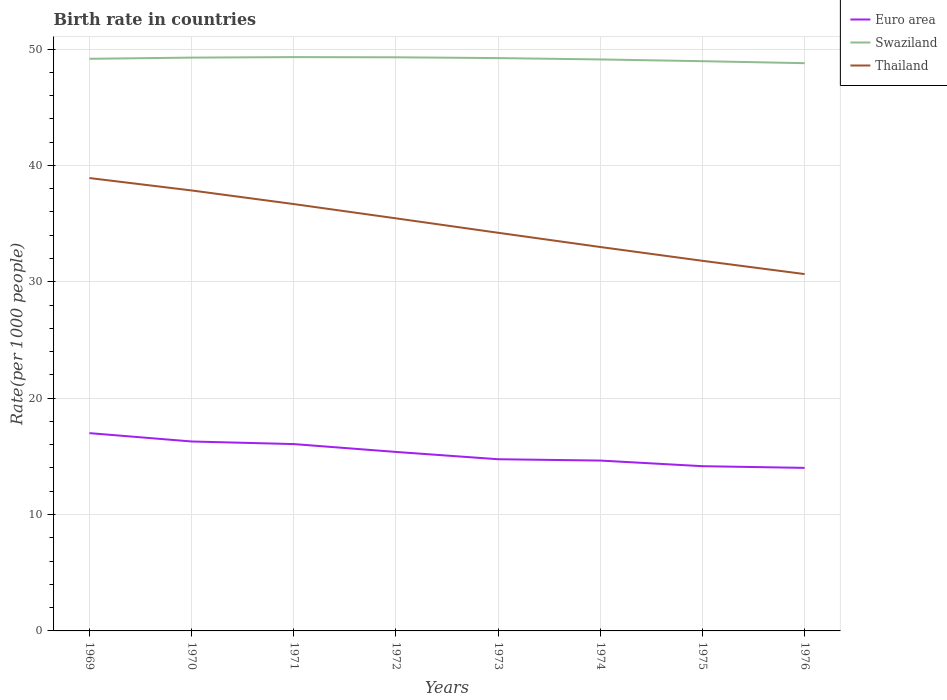How many different coloured lines are there?
Offer a very short reply. 3. Does the line corresponding to Thailand intersect with the line corresponding to Euro area?
Your response must be concise. No. Is the number of lines equal to the number of legend labels?
Offer a very short reply. Yes. Across all years, what is the maximum birth rate in Thailand?
Ensure brevity in your answer.  30.66. In which year was the birth rate in Euro area maximum?
Give a very brief answer. 1976. What is the total birth rate in Thailand in the graph?
Offer a very short reply. 1.24. What is the difference between the highest and the second highest birth rate in Euro area?
Provide a short and direct response. 2.99. What is the difference between the highest and the lowest birth rate in Swaziland?
Keep it short and to the point. 5. Is the birth rate in Euro area strictly greater than the birth rate in Thailand over the years?
Give a very brief answer. Yes. What is the difference between two consecutive major ticks on the Y-axis?
Your answer should be very brief. 10. Where does the legend appear in the graph?
Make the answer very short. Top right. How are the legend labels stacked?
Your answer should be very brief. Vertical. What is the title of the graph?
Provide a succinct answer. Birth rate in countries. Does "Heavily indebted poor countries" appear as one of the legend labels in the graph?
Offer a very short reply. No. What is the label or title of the Y-axis?
Offer a terse response. Rate(per 1000 people). What is the Rate(per 1000 people) of Euro area in 1969?
Make the answer very short. 17. What is the Rate(per 1000 people) in Swaziland in 1969?
Make the answer very short. 49.16. What is the Rate(per 1000 people) of Thailand in 1969?
Give a very brief answer. 38.91. What is the Rate(per 1000 people) of Euro area in 1970?
Your response must be concise. 16.28. What is the Rate(per 1000 people) in Swaziland in 1970?
Provide a short and direct response. 49.26. What is the Rate(per 1000 people) of Thailand in 1970?
Offer a very short reply. 37.85. What is the Rate(per 1000 people) of Euro area in 1971?
Keep it short and to the point. 16.05. What is the Rate(per 1000 people) in Swaziland in 1971?
Your answer should be very brief. 49.3. What is the Rate(per 1000 people) of Thailand in 1971?
Ensure brevity in your answer.  36.68. What is the Rate(per 1000 people) of Euro area in 1972?
Your answer should be very brief. 15.38. What is the Rate(per 1000 people) in Swaziland in 1972?
Offer a terse response. 49.29. What is the Rate(per 1000 people) in Thailand in 1972?
Your response must be concise. 35.45. What is the Rate(per 1000 people) in Euro area in 1973?
Keep it short and to the point. 14.75. What is the Rate(per 1000 people) of Swaziland in 1973?
Ensure brevity in your answer.  49.22. What is the Rate(per 1000 people) in Thailand in 1973?
Provide a short and direct response. 34.21. What is the Rate(per 1000 people) in Euro area in 1974?
Make the answer very short. 14.64. What is the Rate(per 1000 people) of Swaziland in 1974?
Keep it short and to the point. 49.1. What is the Rate(per 1000 people) of Thailand in 1974?
Provide a succinct answer. 32.99. What is the Rate(per 1000 people) in Euro area in 1975?
Provide a short and direct response. 14.15. What is the Rate(per 1000 people) of Swaziland in 1975?
Ensure brevity in your answer.  48.95. What is the Rate(per 1000 people) of Thailand in 1975?
Your answer should be very brief. 31.8. What is the Rate(per 1000 people) in Euro area in 1976?
Give a very brief answer. 14.01. What is the Rate(per 1000 people) of Swaziland in 1976?
Your response must be concise. 48.78. What is the Rate(per 1000 people) of Thailand in 1976?
Make the answer very short. 30.66. Across all years, what is the maximum Rate(per 1000 people) of Euro area?
Your answer should be very brief. 17. Across all years, what is the maximum Rate(per 1000 people) of Swaziland?
Give a very brief answer. 49.3. Across all years, what is the maximum Rate(per 1000 people) of Thailand?
Your answer should be very brief. 38.91. Across all years, what is the minimum Rate(per 1000 people) in Euro area?
Provide a succinct answer. 14.01. Across all years, what is the minimum Rate(per 1000 people) of Swaziland?
Your answer should be very brief. 48.78. Across all years, what is the minimum Rate(per 1000 people) of Thailand?
Offer a very short reply. 30.66. What is the total Rate(per 1000 people) in Euro area in the graph?
Offer a terse response. 122.26. What is the total Rate(per 1000 people) in Swaziland in the graph?
Offer a very short reply. 393.08. What is the total Rate(per 1000 people) of Thailand in the graph?
Provide a short and direct response. 278.55. What is the difference between the Rate(per 1000 people) of Euro area in 1969 and that in 1970?
Your answer should be compact. 0.72. What is the difference between the Rate(per 1000 people) in Swaziland in 1969 and that in 1970?
Provide a succinct answer. -0.1. What is the difference between the Rate(per 1000 people) of Thailand in 1969 and that in 1970?
Ensure brevity in your answer.  1.07. What is the difference between the Rate(per 1000 people) in Euro area in 1969 and that in 1971?
Keep it short and to the point. 0.94. What is the difference between the Rate(per 1000 people) of Swaziland in 1969 and that in 1971?
Keep it short and to the point. -0.14. What is the difference between the Rate(per 1000 people) in Thailand in 1969 and that in 1971?
Your response must be concise. 2.24. What is the difference between the Rate(per 1000 people) of Euro area in 1969 and that in 1972?
Ensure brevity in your answer.  1.62. What is the difference between the Rate(per 1000 people) in Swaziland in 1969 and that in 1972?
Give a very brief answer. -0.13. What is the difference between the Rate(per 1000 people) in Thailand in 1969 and that in 1972?
Offer a terse response. 3.46. What is the difference between the Rate(per 1000 people) of Euro area in 1969 and that in 1973?
Provide a succinct answer. 2.24. What is the difference between the Rate(per 1000 people) in Swaziland in 1969 and that in 1973?
Offer a very short reply. -0.06. What is the difference between the Rate(per 1000 people) in Thailand in 1969 and that in 1973?
Make the answer very short. 4.7. What is the difference between the Rate(per 1000 people) in Euro area in 1969 and that in 1974?
Your answer should be very brief. 2.36. What is the difference between the Rate(per 1000 people) of Swaziland in 1969 and that in 1974?
Your answer should be very brief. 0.06. What is the difference between the Rate(per 1000 people) in Thailand in 1969 and that in 1974?
Ensure brevity in your answer.  5.92. What is the difference between the Rate(per 1000 people) of Euro area in 1969 and that in 1975?
Make the answer very short. 2.84. What is the difference between the Rate(per 1000 people) in Swaziland in 1969 and that in 1975?
Your answer should be compact. 0.2. What is the difference between the Rate(per 1000 people) in Thailand in 1969 and that in 1975?
Your answer should be very brief. 7.11. What is the difference between the Rate(per 1000 people) in Euro area in 1969 and that in 1976?
Provide a short and direct response. 2.99. What is the difference between the Rate(per 1000 people) in Thailand in 1969 and that in 1976?
Ensure brevity in your answer.  8.25. What is the difference between the Rate(per 1000 people) of Euro area in 1970 and that in 1971?
Offer a terse response. 0.22. What is the difference between the Rate(per 1000 people) of Swaziland in 1970 and that in 1971?
Provide a succinct answer. -0.04. What is the difference between the Rate(per 1000 people) of Thailand in 1970 and that in 1971?
Provide a short and direct response. 1.17. What is the difference between the Rate(per 1000 people) in Euro area in 1970 and that in 1972?
Keep it short and to the point. 0.9. What is the difference between the Rate(per 1000 people) in Swaziland in 1970 and that in 1972?
Your answer should be compact. -0.03. What is the difference between the Rate(per 1000 people) in Thailand in 1970 and that in 1972?
Ensure brevity in your answer.  2.4. What is the difference between the Rate(per 1000 people) of Euro area in 1970 and that in 1973?
Offer a very short reply. 1.53. What is the difference between the Rate(per 1000 people) of Swaziland in 1970 and that in 1973?
Provide a succinct answer. 0.04. What is the difference between the Rate(per 1000 people) in Thailand in 1970 and that in 1973?
Offer a terse response. 3.64. What is the difference between the Rate(per 1000 people) in Euro area in 1970 and that in 1974?
Offer a very short reply. 1.64. What is the difference between the Rate(per 1000 people) in Swaziland in 1970 and that in 1974?
Your response must be concise. 0.16. What is the difference between the Rate(per 1000 people) in Thailand in 1970 and that in 1974?
Your answer should be very brief. 4.86. What is the difference between the Rate(per 1000 people) of Euro area in 1970 and that in 1975?
Your answer should be very brief. 2.12. What is the difference between the Rate(per 1000 people) in Swaziland in 1970 and that in 1975?
Keep it short and to the point. 0.31. What is the difference between the Rate(per 1000 people) in Thailand in 1970 and that in 1975?
Your answer should be very brief. 6.04. What is the difference between the Rate(per 1000 people) in Euro area in 1970 and that in 1976?
Make the answer very short. 2.27. What is the difference between the Rate(per 1000 people) of Swaziland in 1970 and that in 1976?
Offer a very short reply. 0.48. What is the difference between the Rate(per 1000 people) in Thailand in 1970 and that in 1976?
Offer a very short reply. 7.19. What is the difference between the Rate(per 1000 people) of Euro area in 1971 and that in 1972?
Your answer should be very brief. 0.68. What is the difference between the Rate(per 1000 people) in Swaziland in 1971 and that in 1972?
Your answer should be very brief. 0.02. What is the difference between the Rate(per 1000 people) in Thailand in 1971 and that in 1972?
Provide a succinct answer. 1.23. What is the difference between the Rate(per 1000 people) in Euro area in 1971 and that in 1973?
Ensure brevity in your answer.  1.3. What is the difference between the Rate(per 1000 people) of Swaziland in 1971 and that in 1973?
Keep it short and to the point. 0.08. What is the difference between the Rate(per 1000 people) in Thailand in 1971 and that in 1973?
Your response must be concise. 2.47. What is the difference between the Rate(per 1000 people) of Euro area in 1971 and that in 1974?
Give a very brief answer. 1.42. What is the difference between the Rate(per 1000 people) in Thailand in 1971 and that in 1974?
Offer a terse response. 3.69. What is the difference between the Rate(per 1000 people) of Euro area in 1971 and that in 1975?
Provide a short and direct response. 1.9. What is the difference between the Rate(per 1000 people) of Swaziland in 1971 and that in 1975?
Make the answer very short. 0.35. What is the difference between the Rate(per 1000 people) in Thailand in 1971 and that in 1975?
Give a very brief answer. 4.88. What is the difference between the Rate(per 1000 people) of Euro area in 1971 and that in 1976?
Make the answer very short. 2.04. What is the difference between the Rate(per 1000 people) in Swaziland in 1971 and that in 1976?
Ensure brevity in your answer.  0.52. What is the difference between the Rate(per 1000 people) in Thailand in 1971 and that in 1976?
Your answer should be very brief. 6.02. What is the difference between the Rate(per 1000 people) in Euro area in 1972 and that in 1973?
Provide a short and direct response. 0.63. What is the difference between the Rate(per 1000 people) of Swaziland in 1972 and that in 1973?
Ensure brevity in your answer.  0.07. What is the difference between the Rate(per 1000 people) of Thailand in 1972 and that in 1973?
Keep it short and to the point. 1.24. What is the difference between the Rate(per 1000 people) of Euro area in 1972 and that in 1974?
Make the answer very short. 0.74. What is the difference between the Rate(per 1000 people) of Swaziland in 1972 and that in 1974?
Provide a short and direct response. 0.18. What is the difference between the Rate(per 1000 people) in Thailand in 1972 and that in 1974?
Ensure brevity in your answer.  2.46. What is the difference between the Rate(per 1000 people) of Euro area in 1972 and that in 1975?
Give a very brief answer. 1.22. What is the difference between the Rate(per 1000 people) in Swaziland in 1972 and that in 1975?
Your answer should be very brief. 0.33. What is the difference between the Rate(per 1000 people) of Thailand in 1972 and that in 1975?
Your answer should be compact. 3.65. What is the difference between the Rate(per 1000 people) in Euro area in 1972 and that in 1976?
Provide a succinct answer. 1.37. What is the difference between the Rate(per 1000 people) in Swaziland in 1972 and that in 1976?
Your response must be concise. 0.5. What is the difference between the Rate(per 1000 people) in Thailand in 1972 and that in 1976?
Make the answer very short. 4.79. What is the difference between the Rate(per 1000 people) of Euro area in 1973 and that in 1974?
Provide a short and direct response. 0.11. What is the difference between the Rate(per 1000 people) in Swaziland in 1973 and that in 1974?
Ensure brevity in your answer.  0.12. What is the difference between the Rate(per 1000 people) in Thailand in 1973 and that in 1974?
Your answer should be very brief. 1.22. What is the difference between the Rate(per 1000 people) in Euro area in 1973 and that in 1975?
Provide a short and direct response. 0.6. What is the difference between the Rate(per 1000 people) of Swaziland in 1973 and that in 1975?
Make the answer very short. 0.27. What is the difference between the Rate(per 1000 people) of Thailand in 1973 and that in 1975?
Provide a short and direct response. 2.41. What is the difference between the Rate(per 1000 people) of Euro area in 1973 and that in 1976?
Ensure brevity in your answer.  0.74. What is the difference between the Rate(per 1000 people) of Swaziland in 1973 and that in 1976?
Your answer should be very brief. 0.44. What is the difference between the Rate(per 1000 people) of Thailand in 1973 and that in 1976?
Give a very brief answer. 3.55. What is the difference between the Rate(per 1000 people) in Euro area in 1974 and that in 1975?
Your answer should be compact. 0.48. What is the difference between the Rate(per 1000 people) of Swaziland in 1974 and that in 1975?
Provide a succinct answer. 0.15. What is the difference between the Rate(per 1000 people) in Thailand in 1974 and that in 1975?
Offer a terse response. 1.19. What is the difference between the Rate(per 1000 people) of Euro area in 1974 and that in 1976?
Make the answer very short. 0.63. What is the difference between the Rate(per 1000 people) in Swaziland in 1974 and that in 1976?
Keep it short and to the point. 0.32. What is the difference between the Rate(per 1000 people) in Thailand in 1974 and that in 1976?
Ensure brevity in your answer.  2.33. What is the difference between the Rate(per 1000 people) in Euro area in 1975 and that in 1976?
Your response must be concise. 0.14. What is the difference between the Rate(per 1000 people) in Swaziland in 1975 and that in 1976?
Your answer should be very brief. 0.17. What is the difference between the Rate(per 1000 people) in Thailand in 1975 and that in 1976?
Your answer should be very brief. 1.14. What is the difference between the Rate(per 1000 people) of Euro area in 1969 and the Rate(per 1000 people) of Swaziland in 1970?
Offer a terse response. -32.27. What is the difference between the Rate(per 1000 people) of Euro area in 1969 and the Rate(per 1000 people) of Thailand in 1970?
Give a very brief answer. -20.85. What is the difference between the Rate(per 1000 people) in Swaziland in 1969 and the Rate(per 1000 people) in Thailand in 1970?
Offer a terse response. 11.31. What is the difference between the Rate(per 1000 people) of Euro area in 1969 and the Rate(per 1000 people) of Swaziland in 1971?
Your response must be concise. -32.31. What is the difference between the Rate(per 1000 people) of Euro area in 1969 and the Rate(per 1000 people) of Thailand in 1971?
Offer a terse response. -19.68. What is the difference between the Rate(per 1000 people) in Swaziland in 1969 and the Rate(per 1000 people) in Thailand in 1971?
Ensure brevity in your answer.  12.48. What is the difference between the Rate(per 1000 people) of Euro area in 1969 and the Rate(per 1000 people) of Swaziland in 1972?
Your answer should be very brief. -32.29. What is the difference between the Rate(per 1000 people) of Euro area in 1969 and the Rate(per 1000 people) of Thailand in 1972?
Give a very brief answer. -18.46. What is the difference between the Rate(per 1000 people) of Swaziland in 1969 and the Rate(per 1000 people) of Thailand in 1972?
Your answer should be very brief. 13.71. What is the difference between the Rate(per 1000 people) of Euro area in 1969 and the Rate(per 1000 people) of Swaziland in 1973?
Give a very brief answer. -32.23. What is the difference between the Rate(per 1000 people) in Euro area in 1969 and the Rate(per 1000 people) in Thailand in 1973?
Give a very brief answer. -17.22. What is the difference between the Rate(per 1000 people) of Swaziland in 1969 and the Rate(per 1000 people) of Thailand in 1973?
Offer a terse response. 14.95. What is the difference between the Rate(per 1000 people) in Euro area in 1969 and the Rate(per 1000 people) in Swaziland in 1974?
Make the answer very short. -32.11. What is the difference between the Rate(per 1000 people) of Euro area in 1969 and the Rate(per 1000 people) of Thailand in 1974?
Provide a succinct answer. -15.99. What is the difference between the Rate(per 1000 people) of Swaziland in 1969 and the Rate(per 1000 people) of Thailand in 1974?
Your answer should be compact. 16.17. What is the difference between the Rate(per 1000 people) in Euro area in 1969 and the Rate(per 1000 people) in Swaziland in 1975?
Offer a terse response. -31.96. What is the difference between the Rate(per 1000 people) in Euro area in 1969 and the Rate(per 1000 people) in Thailand in 1975?
Your response must be concise. -14.81. What is the difference between the Rate(per 1000 people) in Swaziland in 1969 and the Rate(per 1000 people) in Thailand in 1975?
Ensure brevity in your answer.  17.36. What is the difference between the Rate(per 1000 people) in Euro area in 1969 and the Rate(per 1000 people) in Swaziland in 1976?
Your answer should be compact. -31.79. What is the difference between the Rate(per 1000 people) in Euro area in 1969 and the Rate(per 1000 people) in Thailand in 1976?
Make the answer very short. -13.67. What is the difference between the Rate(per 1000 people) of Swaziland in 1969 and the Rate(per 1000 people) of Thailand in 1976?
Your answer should be very brief. 18.5. What is the difference between the Rate(per 1000 people) in Euro area in 1970 and the Rate(per 1000 people) in Swaziland in 1971?
Your answer should be very brief. -33.03. What is the difference between the Rate(per 1000 people) in Euro area in 1970 and the Rate(per 1000 people) in Thailand in 1971?
Make the answer very short. -20.4. What is the difference between the Rate(per 1000 people) of Swaziland in 1970 and the Rate(per 1000 people) of Thailand in 1971?
Ensure brevity in your answer.  12.59. What is the difference between the Rate(per 1000 people) of Euro area in 1970 and the Rate(per 1000 people) of Swaziland in 1972?
Give a very brief answer. -33.01. What is the difference between the Rate(per 1000 people) in Euro area in 1970 and the Rate(per 1000 people) in Thailand in 1972?
Keep it short and to the point. -19.17. What is the difference between the Rate(per 1000 people) in Swaziland in 1970 and the Rate(per 1000 people) in Thailand in 1972?
Provide a short and direct response. 13.81. What is the difference between the Rate(per 1000 people) of Euro area in 1970 and the Rate(per 1000 people) of Swaziland in 1973?
Make the answer very short. -32.94. What is the difference between the Rate(per 1000 people) of Euro area in 1970 and the Rate(per 1000 people) of Thailand in 1973?
Keep it short and to the point. -17.93. What is the difference between the Rate(per 1000 people) in Swaziland in 1970 and the Rate(per 1000 people) in Thailand in 1973?
Give a very brief answer. 15.05. What is the difference between the Rate(per 1000 people) in Euro area in 1970 and the Rate(per 1000 people) in Swaziland in 1974?
Your answer should be very brief. -32.83. What is the difference between the Rate(per 1000 people) in Euro area in 1970 and the Rate(per 1000 people) in Thailand in 1974?
Ensure brevity in your answer.  -16.71. What is the difference between the Rate(per 1000 people) of Swaziland in 1970 and the Rate(per 1000 people) of Thailand in 1974?
Give a very brief answer. 16.27. What is the difference between the Rate(per 1000 people) of Euro area in 1970 and the Rate(per 1000 people) of Swaziland in 1975?
Your answer should be compact. -32.68. What is the difference between the Rate(per 1000 people) in Euro area in 1970 and the Rate(per 1000 people) in Thailand in 1975?
Keep it short and to the point. -15.52. What is the difference between the Rate(per 1000 people) of Swaziland in 1970 and the Rate(per 1000 people) of Thailand in 1975?
Offer a terse response. 17.46. What is the difference between the Rate(per 1000 people) in Euro area in 1970 and the Rate(per 1000 people) in Swaziland in 1976?
Make the answer very short. -32.51. What is the difference between the Rate(per 1000 people) in Euro area in 1970 and the Rate(per 1000 people) in Thailand in 1976?
Give a very brief answer. -14.38. What is the difference between the Rate(per 1000 people) in Swaziland in 1970 and the Rate(per 1000 people) in Thailand in 1976?
Provide a short and direct response. 18.6. What is the difference between the Rate(per 1000 people) of Euro area in 1971 and the Rate(per 1000 people) of Swaziland in 1972?
Your response must be concise. -33.23. What is the difference between the Rate(per 1000 people) of Euro area in 1971 and the Rate(per 1000 people) of Thailand in 1972?
Provide a short and direct response. -19.4. What is the difference between the Rate(per 1000 people) in Swaziland in 1971 and the Rate(per 1000 people) in Thailand in 1972?
Provide a short and direct response. 13.85. What is the difference between the Rate(per 1000 people) of Euro area in 1971 and the Rate(per 1000 people) of Swaziland in 1973?
Offer a terse response. -33.17. What is the difference between the Rate(per 1000 people) of Euro area in 1971 and the Rate(per 1000 people) of Thailand in 1973?
Keep it short and to the point. -18.16. What is the difference between the Rate(per 1000 people) of Swaziland in 1971 and the Rate(per 1000 people) of Thailand in 1973?
Your answer should be very brief. 15.09. What is the difference between the Rate(per 1000 people) of Euro area in 1971 and the Rate(per 1000 people) of Swaziland in 1974?
Your answer should be compact. -33.05. What is the difference between the Rate(per 1000 people) of Euro area in 1971 and the Rate(per 1000 people) of Thailand in 1974?
Provide a succinct answer. -16.93. What is the difference between the Rate(per 1000 people) in Swaziland in 1971 and the Rate(per 1000 people) in Thailand in 1974?
Give a very brief answer. 16.32. What is the difference between the Rate(per 1000 people) in Euro area in 1971 and the Rate(per 1000 people) in Swaziland in 1975?
Ensure brevity in your answer.  -32.9. What is the difference between the Rate(per 1000 people) in Euro area in 1971 and the Rate(per 1000 people) in Thailand in 1975?
Your response must be concise. -15.75. What is the difference between the Rate(per 1000 people) of Swaziland in 1971 and the Rate(per 1000 people) of Thailand in 1975?
Your answer should be very brief. 17.5. What is the difference between the Rate(per 1000 people) in Euro area in 1971 and the Rate(per 1000 people) in Swaziland in 1976?
Ensure brevity in your answer.  -32.73. What is the difference between the Rate(per 1000 people) of Euro area in 1971 and the Rate(per 1000 people) of Thailand in 1976?
Your answer should be very brief. -14.61. What is the difference between the Rate(per 1000 people) of Swaziland in 1971 and the Rate(per 1000 people) of Thailand in 1976?
Ensure brevity in your answer.  18.64. What is the difference between the Rate(per 1000 people) of Euro area in 1972 and the Rate(per 1000 people) of Swaziland in 1973?
Provide a short and direct response. -33.84. What is the difference between the Rate(per 1000 people) in Euro area in 1972 and the Rate(per 1000 people) in Thailand in 1973?
Give a very brief answer. -18.83. What is the difference between the Rate(per 1000 people) of Swaziland in 1972 and the Rate(per 1000 people) of Thailand in 1973?
Make the answer very short. 15.08. What is the difference between the Rate(per 1000 people) in Euro area in 1972 and the Rate(per 1000 people) in Swaziland in 1974?
Offer a terse response. -33.73. What is the difference between the Rate(per 1000 people) in Euro area in 1972 and the Rate(per 1000 people) in Thailand in 1974?
Keep it short and to the point. -17.61. What is the difference between the Rate(per 1000 people) in Swaziland in 1972 and the Rate(per 1000 people) in Thailand in 1974?
Give a very brief answer. 16.3. What is the difference between the Rate(per 1000 people) of Euro area in 1972 and the Rate(per 1000 people) of Swaziland in 1975?
Provide a succinct answer. -33.58. What is the difference between the Rate(per 1000 people) of Euro area in 1972 and the Rate(per 1000 people) of Thailand in 1975?
Make the answer very short. -16.42. What is the difference between the Rate(per 1000 people) in Swaziland in 1972 and the Rate(per 1000 people) in Thailand in 1975?
Keep it short and to the point. 17.49. What is the difference between the Rate(per 1000 people) in Euro area in 1972 and the Rate(per 1000 people) in Swaziland in 1976?
Offer a very short reply. -33.41. What is the difference between the Rate(per 1000 people) of Euro area in 1972 and the Rate(per 1000 people) of Thailand in 1976?
Offer a very short reply. -15.28. What is the difference between the Rate(per 1000 people) in Swaziland in 1972 and the Rate(per 1000 people) in Thailand in 1976?
Ensure brevity in your answer.  18.63. What is the difference between the Rate(per 1000 people) in Euro area in 1973 and the Rate(per 1000 people) in Swaziland in 1974?
Offer a terse response. -34.35. What is the difference between the Rate(per 1000 people) of Euro area in 1973 and the Rate(per 1000 people) of Thailand in 1974?
Provide a short and direct response. -18.24. What is the difference between the Rate(per 1000 people) in Swaziland in 1973 and the Rate(per 1000 people) in Thailand in 1974?
Provide a succinct answer. 16.23. What is the difference between the Rate(per 1000 people) of Euro area in 1973 and the Rate(per 1000 people) of Swaziland in 1975?
Offer a very short reply. -34.2. What is the difference between the Rate(per 1000 people) of Euro area in 1973 and the Rate(per 1000 people) of Thailand in 1975?
Offer a terse response. -17.05. What is the difference between the Rate(per 1000 people) in Swaziland in 1973 and the Rate(per 1000 people) in Thailand in 1975?
Offer a very short reply. 17.42. What is the difference between the Rate(per 1000 people) of Euro area in 1973 and the Rate(per 1000 people) of Swaziland in 1976?
Your answer should be very brief. -34.03. What is the difference between the Rate(per 1000 people) of Euro area in 1973 and the Rate(per 1000 people) of Thailand in 1976?
Your answer should be very brief. -15.91. What is the difference between the Rate(per 1000 people) of Swaziland in 1973 and the Rate(per 1000 people) of Thailand in 1976?
Ensure brevity in your answer.  18.56. What is the difference between the Rate(per 1000 people) of Euro area in 1974 and the Rate(per 1000 people) of Swaziland in 1975?
Your answer should be very brief. -34.32. What is the difference between the Rate(per 1000 people) of Euro area in 1974 and the Rate(per 1000 people) of Thailand in 1975?
Offer a terse response. -17.16. What is the difference between the Rate(per 1000 people) of Swaziland in 1974 and the Rate(per 1000 people) of Thailand in 1975?
Offer a terse response. 17.3. What is the difference between the Rate(per 1000 people) in Euro area in 1974 and the Rate(per 1000 people) in Swaziland in 1976?
Keep it short and to the point. -34.15. What is the difference between the Rate(per 1000 people) of Euro area in 1974 and the Rate(per 1000 people) of Thailand in 1976?
Give a very brief answer. -16.02. What is the difference between the Rate(per 1000 people) of Swaziland in 1974 and the Rate(per 1000 people) of Thailand in 1976?
Provide a succinct answer. 18.44. What is the difference between the Rate(per 1000 people) of Euro area in 1975 and the Rate(per 1000 people) of Swaziland in 1976?
Keep it short and to the point. -34.63. What is the difference between the Rate(per 1000 people) of Euro area in 1975 and the Rate(per 1000 people) of Thailand in 1976?
Make the answer very short. -16.51. What is the difference between the Rate(per 1000 people) of Swaziland in 1975 and the Rate(per 1000 people) of Thailand in 1976?
Make the answer very short. 18.29. What is the average Rate(per 1000 people) of Euro area per year?
Ensure brevity in your answer.  15.28. What is the average Rate(per 1000 people) of Swaziland per year?
Your answer should be compact. 49.14. What is the average Rate(per 1000 people) of Thailand per year?
Your answer should be very brief. 34.82. In the year 1969, what is the difference between the Rate(per 1000 people) of Euro area and Rate(per 1000 people) of Swaziland?
Provide a succinct answer. -32.16. In the year 1969, what is the difference between the Rate(per 1000 people) of Euro area and Rate(per 1000 people) of Thailand?
Ensure brevity in your answer.  -21.92. In the year 1969, what is the difference between the Rate(per 1000 people) in Swaziland and Rate(per 1000 people) in Thailand?
Your response must be concise. 10.25. In the year 1970, what is the difference between the Rate(per 1000 people) of Euro area and Rate(per 1000 people) of Swaziland?
Provide a short and direct response. -32.98. In the year 1970, what is the difference between the Rate(per 1000 people) in Euro area and Rate(per 1000 people) in Thailand?
Provide a succinct answer. -21.57. In the year 1970, what is the difference between the Rate(per 1000 people) of Swaziland and Rate(per 1000 people) of Thailand?
Provide a succinct answer. 11.41. In the year 1971, what is the difference between the Rate(per 1000 people) in Euro area and Rate(per 1000 people) in Swaziland?
Your answer should be very brief. -33.25. In the year 1971, what is the difference between the Rate(per 1000 people) of Euro area and Rate(per 1000 people) of Thailand?
Keep it short and to the point. -20.62. In the year 1971, what is the difference between the Rate(per 1000 people) in Swaziland and Rate(per 1000 people) in Thailand?
Your answer should be very brief. 12.63. In the year 1972, what is the difference between the Rate(per 1000 people) of Euro area and Rate(per 1000 people) of Swaziland?
Offer a terse response. -33.91. In the year 1972, what is the difference between the Rate(per 1000 people) in Euro area and Rate(per 1000 people) in Thailand?
Provide a short and direct response. -20.07. In the year 1972, what is the difference between the Rate(per 1000 people) of Swaziland and Rate(per 1000 people) of Thailand?
Provide a succinct answer. 13.84. In the year 1973, what is the difference between the Rate(per 1000 people) of Euro area and Rate(per 1000 people) of Swaziland?
Make the answer very short. -34.47. In the year 1973, what is the difference between the Rate(per 1000 people) in Euro area and Rate(per 1000 people) in Thailand?
Ensure brevity in your answer.  -19.46. In the year 1973, what is the difference between the Rate(per 1000 people) in Swaziland and Rate(per 1000 people) in Thailand?
Your answer should be very brief. 15.01. In the year 1974, what is the difference between the Rate(per 1000 people) in Euro area and Rate(per 1000 people) in Swaziland?
Your answer should be very brief. -34.47. In the year 1974, what is the difference between the Rate(per 1000 people) in Euro area and Rate(per 1000 people) in Thailand?
Provide a short and direct response. -18.35. In the year 1974, what is the difference between the Rate(per 1000 people) in Swaziland and Rate(per 1000 people) in Thailand?
Offer a terse response. 16.12. In the year 1975, what is the difference between the Rate(per 1000 people) in Euro area and Rate(per 1000 people) in Swaziland?
Provide a succinct answer. -34.8. In the year 1975, what is the difference between the Rate(per 1000 people) in Euro area and Rate(per 1000 people) in Thailand?
Your answer should be very brief. -17.65. In the year 1975, what is the difference between the Rate(per 1000 people) of Swaziland and Rate(per 1000 people) of Thailand?
Give a very brief answer. 17.15. In the year 1976, what is the difference between the Rate(per 1000 people) of Euro area and Rate(per 1000 people) of Swaziland?
Make the answer very short. -34.77. In the year 1976, what is the difference between the Rate(per 1000 people) in Euro area and Rate(per 1000 people) in Thailand?
Your answer should be very brief. -16.65. In the year 1976, what is the difference between the Rate(per 1000 people) of Swaziland and Rate(per 1000 people) of Thailand?
Ensure brevity in your answer.  18.12. What is the ratio of the Rate(per 1000 people) of Euro area in 1969 to that in 1970?
Offer a terse response. 1.04. What is the ratio of the Rate(per 1000 people) in Swaziland in 1969 to that in 1970?
Make the answer very short. 1. What is the ratio of the Rate(per 1000 people) in Thailand in 1969 to that in 1970?
Offer a very short reply. 1.03. What is the ratio of the Rate(per 1000 people) in Euro area in 1969 to that in 1971?
Provide a succinct answer. 1.06. What is the ratio of the Rate(per 1000 people) in Thailand in 1969 to that in 1971?
Provide a succinct answer. 1.06. What is the ratio of the Rate(per 1000 people) in Euro area in 1969 to that in 1972?
Your response must be concise. 1.11. What is the ratio of the Rate(per 1000 people) of Thailand in 1969 to that in 1972?
Ensure brevity in your answer.  1.1. What is the ratio of the Rate(per 1000 people) in Euro area in 1969 to that in 1973?
Ensure brevity in your answer.  1.15. What is the ratio of the Rate(per 1000 people) in Swaziland in 1969 to that in 1973?
Provide a short and direct response. 1. What is the ratio of the Rate(per 1000 people) in Thailand in 1969 to that in 1973?
Provide a succinct answer. 1.14. What is the ratio of the Rate(per 1000 people) of Euro area in 1969 to that in 1974?
Offer a terse response. 1.16. What is the ratio of the Rate(per 1000 people) of Swaziland in 1969 to that in 1974?
Provide a short and direct response. 1. What is the ratio of the Rate(per 1000 people) in Thailand in 1969 to that in 1974?
Ensure brevity in your answer.  1.18. What is the ratio of the Rate(per 1000 people) in Euro area in 1969 to that in 1975?
Offer a very short reply. 1.2. What is the ratio of the Rate(per 1000 people) of Thailand in 1969 to that in 1975?
Offer a very short reply. 1.22. What is the ratio of the Rate(per 1000 people) of Euro area in 1969 to that in 1976?
Keep it short and to the point. 1.21. What is the ratio of the Rate(per 1000 people) of Swaziland in 1969 to that in 1976?
Offer a very short reply. 1.01. What is the ratio of the Rate(per 1000 people) in Thailand in 1969 to that in 1976?
Offer a terse response. 1.27. What is the ratio of the Rate(per 1000 people) in Euro area in 1970 to that in 1971?
Offer a terse response. 1.01. What is the ratio of the Rate(per 1000 people) of Thailand in 1970 to that in 1971?
Provide a short and direct response. 1.03. What is the ratio of the Rate(per 1000 people) in Euro area in 1970 to that in 1972?
Keep it short and to the point. 1.06. What is the ratio of the Rate(per 1000 people) in Thailand in 1970 to that in 1972?
Give a very brief answer. 1.07. What is the ratio of the Rate(per 1000 people) in Euro area in 1970 to that in 1973?
Offer a very short reply. 1.1. What is the ratio of the Rate(per 1000 people) in Thailand in 1970 to that in 1973?
Provide a succinct answer. 1.11. What is the ratio of the Rate(per 1000 people) of Euro area in 1970 to that in 1974?
Provide a succinct answer. 1.11. What is the ratio of the Rate(per 1000 people) in Thailand in 1970 to that in 1974?
Offer a very short reply. 1.15. What is the ratio of the Rate(per 1000 people) of Euro area in 1970 to that in 1975?
Offer a very short reply. 1.15. What is the ratio of the Rate(per 1000 people) in Thailand in 1970 to that in 1975?
Provide a short and direct response. 1.19. What is the ratio of the Rate(per 1000 people) in Euro area in 1970 to that in 1976?
Keep it short and to the point. 1.16. What is the ratio of the Rate(per 1000 people) of Swaziland in 1970 to that in 1976?
Offer a very short reply. 1.01. What is the ratio of the Rate(per 1000 people) in Thailand in 1970 to that in 1976?
Ensure brevity in your answer.  1.23. What is the ratio of the Rate(per 1000 people) of Euro area in 1971 to that in 1972?
Your response must be concise. 1.04. What is the ratio of the Rate(per 1000 people) in Thailand in 1971 to that in 1972?
Provide a succinct answer. 1.03. What is the ratio of the Rate(per 1000 people) of Euro area in 1971 to that in 1973?
Your response must be concise. 1.09. What is the ratio of the Rate(per 1000 people) of Thailand in 1971 to that in 1973?
Make the answer very short. 1.07. What is the ratio of the Rate(per 1000 people) in Euro area in 1971 to that in 1974?
Your response must be concise. 1.1. What is the ratio of the Rate(per 1000 people) in Swaziland in 1971 to that in 1974?
Keep it short and to the point. 1. What is the ratio of the Rate(per 1000 people) of Thailand in 1971 to that in 1974?
Make the answer very short. 1.11. What is the ratio of the Rate(per 1000 people) in Euro area in 1971 to that in 1975?
Your response must be concise. 1.13. What is the ratio of the Rate(per 1000 people) in Swaziland in 1971 to that in 1975?
Ensure brevity in your answer.  1.01. What is the ratio of the Rate(per 1000 people) of Thailand in 1971 to that in 1975?
Your answer should be compact. 1.15. What is the ratio of the Rate(per 1000 people) of Euro area in 1971 to that in 1976?
Ensure brevity in your answer.  1.15. What is the ratio of the Rate(per 1000 people) of Swaziland in 1971 to that in 1976?
Keep it short and to the point. 1.01. What is the ratio of the Rate(per 1000 people) in Thailand in 1971 to that in 1976?
Ensure brevity in your answer.  1.2. What is the ratio of the Rate(per 1000 people) in Euro area in 1972 to that in 1973?
Ensure brevity in your answer.  1.04. What is the ratio of the Rate(per 1000 people) in Thailand in 1972 to that in 1973?
Give a very brief answer. 1.04. What is the ratio of the Rate(per 1000 people) of Euro area in 1972 to that in 1974?
Make the answer very short. 1.05. What is the ratio of the Rate(per 1000 people) of Swaziland in 1972 to that in 1974?
Your answer should be compact. 1. What is the ratio of the Rate(per 1000 people) of Thailand in 1972 to that in 1974?
Offer a very short reply. 1.07. What is the ratio of the Rate(per 1000 people) of Euro area in 1972 to that in 1975?
Keep it short and to the point. 1.09. What is the ratio of the Rate(per 1000 people) of Swaziland in 1972 to that in 1975?
Provide a short and direct response. 1.01. What is the ratio of the Rate(per 1000 people) in Thailand in 1972 to that in 1975?
Give a very brief answer. 1.11. What is the ratio of the Rate(per 1000 people) in Euro area in 1972 to that in 1976?
Provide a succinct answer. 1.1. What is the ratio of the Rate(per 1000 people) in Swaziland in 1972 to that in 1976?
Offer a very short reply. 1.01. What is the ratio of the Rate(per 1000 people) of Thailand in 1972 to that in 1976?
Provide a short and direct response. 1.16. What is the ratio of the Rate(per 1000 people) of Thailand in 1973 to that in 1974?
Provide a succinct answer. 1.04. What is the ratio of the Rate(per 1000 people) of Euro area in 1973 to that in 1975?
Provide a short and direct response. 1.04. What is the ratio of the Rate(per 1000 people) of Swaziland in 1973 to that in 1975?
Give a very brief answer. 1.01. What is the ratio of the Rate(per 1000 people) of Thailand in 1973 to that in 1975?
Ensure brevity in your answer.  1.08. What is the ratio of the Rate(per 1000 people) of Euro area in 1973 to that in 1976?
Provide a short and direct response. 1.05. What is the ratio of the Rate(per 1000 people) of Swaziland in 1973 to that in 1976?
Make the answer very short. 1.01. What is the ratio of the Rate(per 1000 people) in Thailand in 1973 to that in 1976?
Provide a succinct answer. 1.12. What is the ratio of the Rate(per 1000 people) in Euro area in 1974 to that in 1975?
Offer a very short reply. 1.03. What is the ratio of the Rate(per 1000 people) of Swaziland in 1974 to that in 1975?
Your response must be concise. 1. What is the ratio of the Rate(per 1000 people) in Thailand in 1974 to that in 1975?
Your response must be concise. 1.04. What is the ratio of the Rate(per 1000 people) in Euro area in 1974 to that in 1976?
Your response must be concise. 1.04. What is the ratio of the Rate(per 1000 people) in Swaziland in 1974 to that in 1976?
Your response must be concise. 1.01. What is the ratio of the Rate(per 1000 people) of Thailand in 1974 to that in 1976?
Offer a very short reply. 1.08. What is the ratio of the Rate(per 1000 people) in Euro area in 1975 to that in 1976?
Make the answer very short. 1.01. What is the ratio of the Rate(per 1000 people) in Thailand in 1975 to that in 1976?
Provide a short and direct response. 1.04. What is the difference between the highest and the second highest Rate(per 1000 people) in Euro area?
Your answer should be very brief. 0.72. What is the difference between the highest and the second highest Rate(per 1000 people) of Swaziland?
Ensure brevity in your answer.  0.02. What is the difference between the highest and the second highest Rate(per 1000 people) of Thailand?
Provide a short and direct response. 1.07. What is the difference between the highest and the lowest Rate(per 1000 people) in Euro area?
Provide a short and direct response. 2.99. What is the difference between the highest and the lowest Rate(per 1000 people) in Swaziland?
Give a very brief answer. 0.52. What is the difference between the highest and the lowest Rate(per 1000 people) in Thailand?
Make the answer very short. 8.25. 